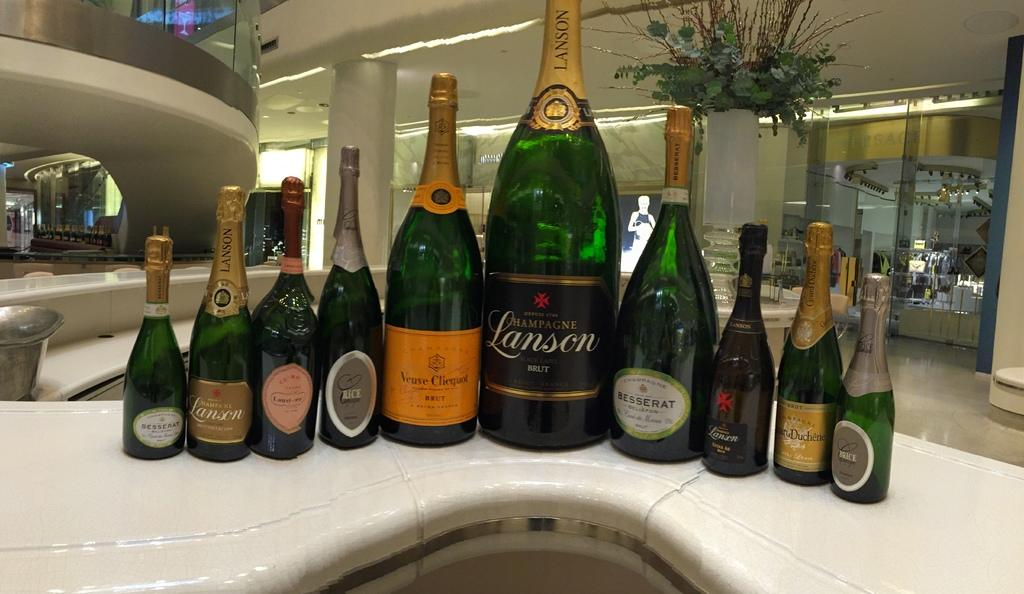<image>
Relay a brief, clear account of the picture shown. A very large green glass bottle of Lanson Champagne centered by descending smaller bottles on a white counter top. 